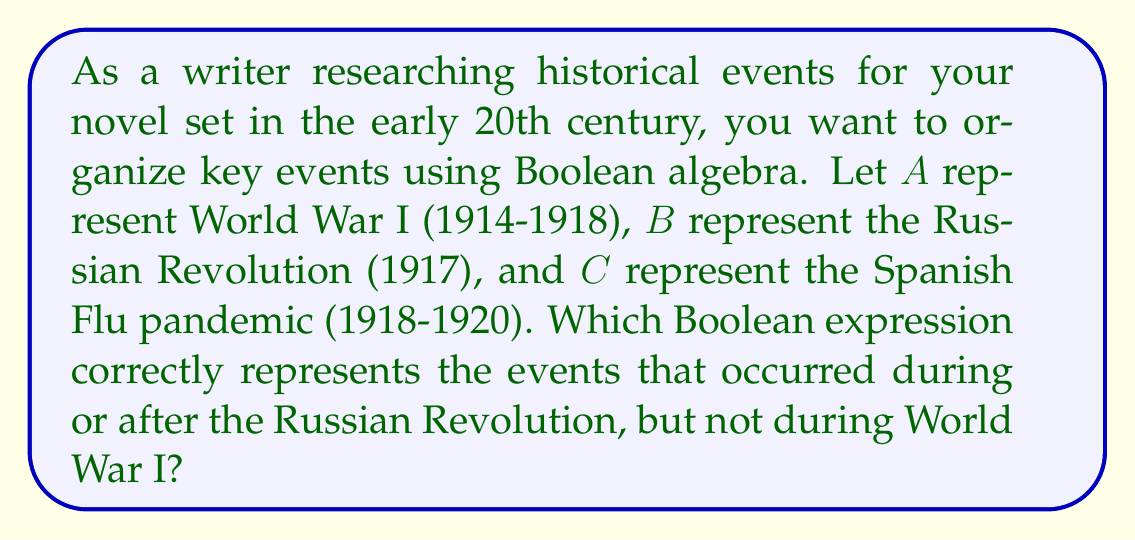What is the answer to this math problem? To solve this problem, we need to break it down into steps using Boolean algebra:

1. Events during or after the Russian Revolution: $B + C$
   This is because the Russian Revolution ($B$) and the Spanish Flu pandemic ($C$) both occurred in 1917 or later.

2. Events not during World War I: $\overline{A}$
   The complement of $A$ represents all events that did not occur during World War I.

3. Combine the two conditions using the AND operation:
   $$(B + C) \cdot \overline{A}$$

4. Expand the expression using the distributive property:
   $$(B \cdot \overline{A}) + (C \cdot \overline{A})$$

This final expression represents events that occurred during or after the Russian Revolution (B + C) AND not during World War I ($\overline{A}$).

For the historical context:
- The Russian Revolution ($B$) occurred in 1917, which was during World War I, so $B \cdot \overline{A}$ would be false.
- The Spanish Flu pandemic ($C$) started in 1918 and continued after World War I ended, so $C \cdot \overline{A}$ would be true for the period after World War I.

Therefore, this Boolean expression correctly organizes the events according to the given criteria.
Answer: $(B + C) \cdot \overline{A}$ 